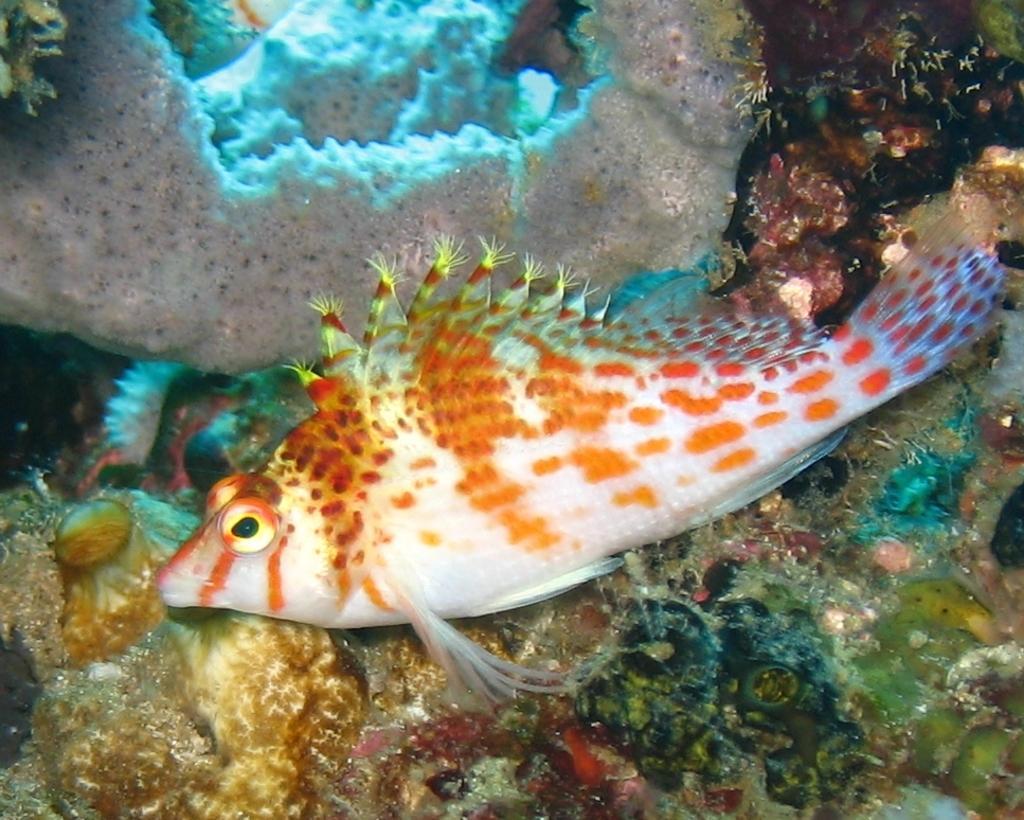How would you summarize this image in a sentence or two? This image is taken in an aquarium. In the middle of the image there is a fish in the water, which is orange and white in colors. In the background there are many coral reefs. 